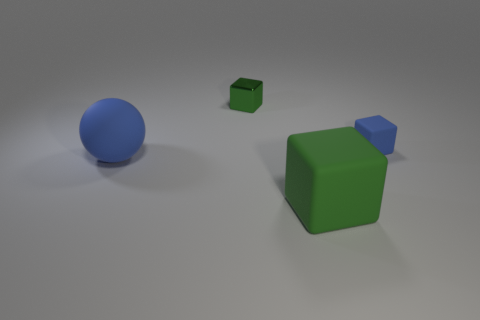What material is the large blue thing?
Offer a terse response. Rubber. The object that is the same size as the blue matte sphere is what color?
Your response must be concise. Green. What shape is the rubber object that is the same color as the small shiny block?
Keep it short and to the point. Cube. Is the big blue matte thing the same shape as the small matte object?
Keep it short and to the point. No. What material is the thing that is both in front of the tiny green thing and behind the blue rubber sphere?
Make the answer very short. Rubber. The metallic object has what size?
Keep it short and to the point. Small. The other tiny object that is the same shape as the small blue matte thing is what color?
Offer a terse response. Green. Is there any other thing of the same color as the small rubber object?
Make the answer very short. Yes. Do the blue object that is behind the blue rubber sphere and the matte object that is to the left of the big green object have the same size?
Provide a short and direct response. No. Is the number of objects right of the sphere the same as the number of blue rubber objects that are behind the small matte block?
Keep it short and to the point. No. 